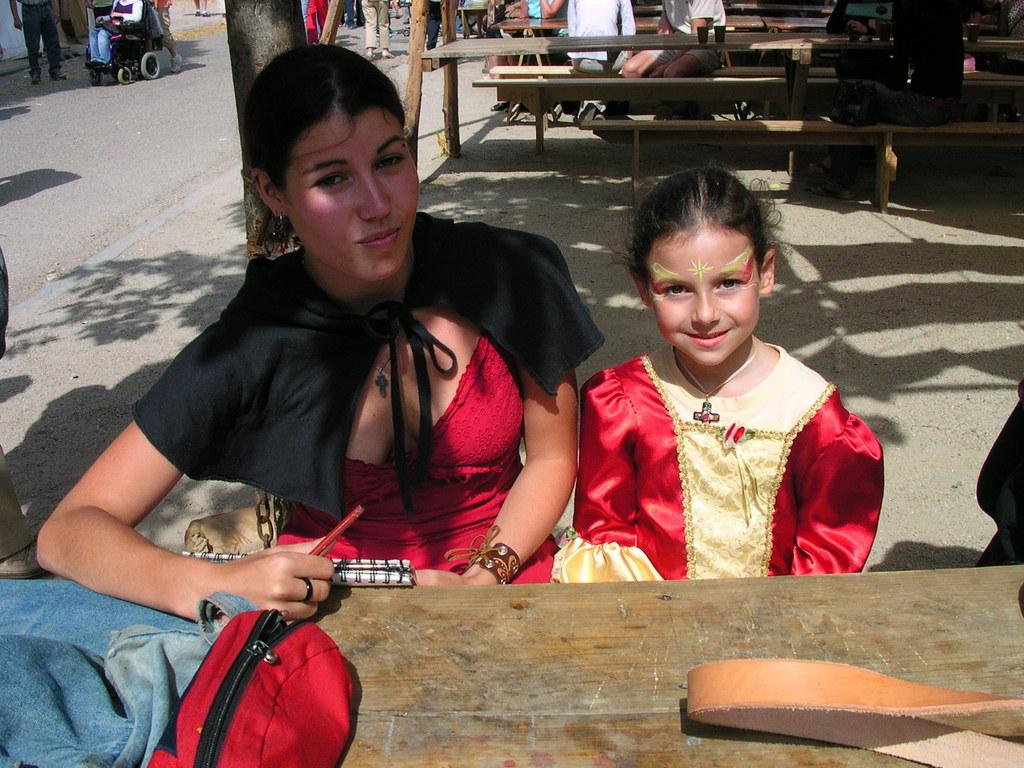What is the woman in the image wearing? The woman is wearing a red dress. Who is sitting beside the woman in the image? There is a little girl sitting beside the woman. What is the expression on the little girl's face? The little girl is smiling. What can be seen on the left side of the image? There is a bag on a table in the left side of the image. What type of bridge can be seen in the background of the image? There is no bridge visible in the image. 